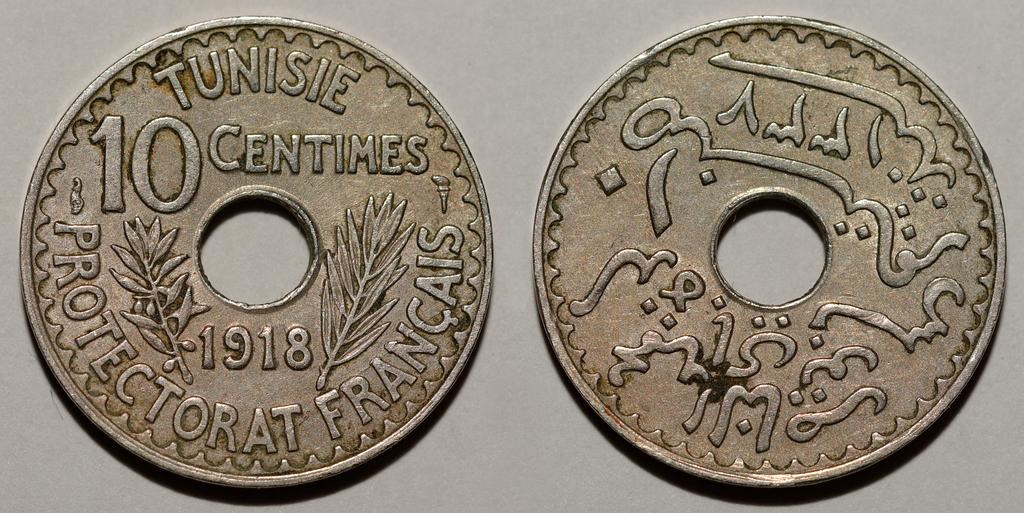<image>
Relay a brief, clear account of the picture shown. Two coins with holes in the centre and the one on the left reading 10 centimes 